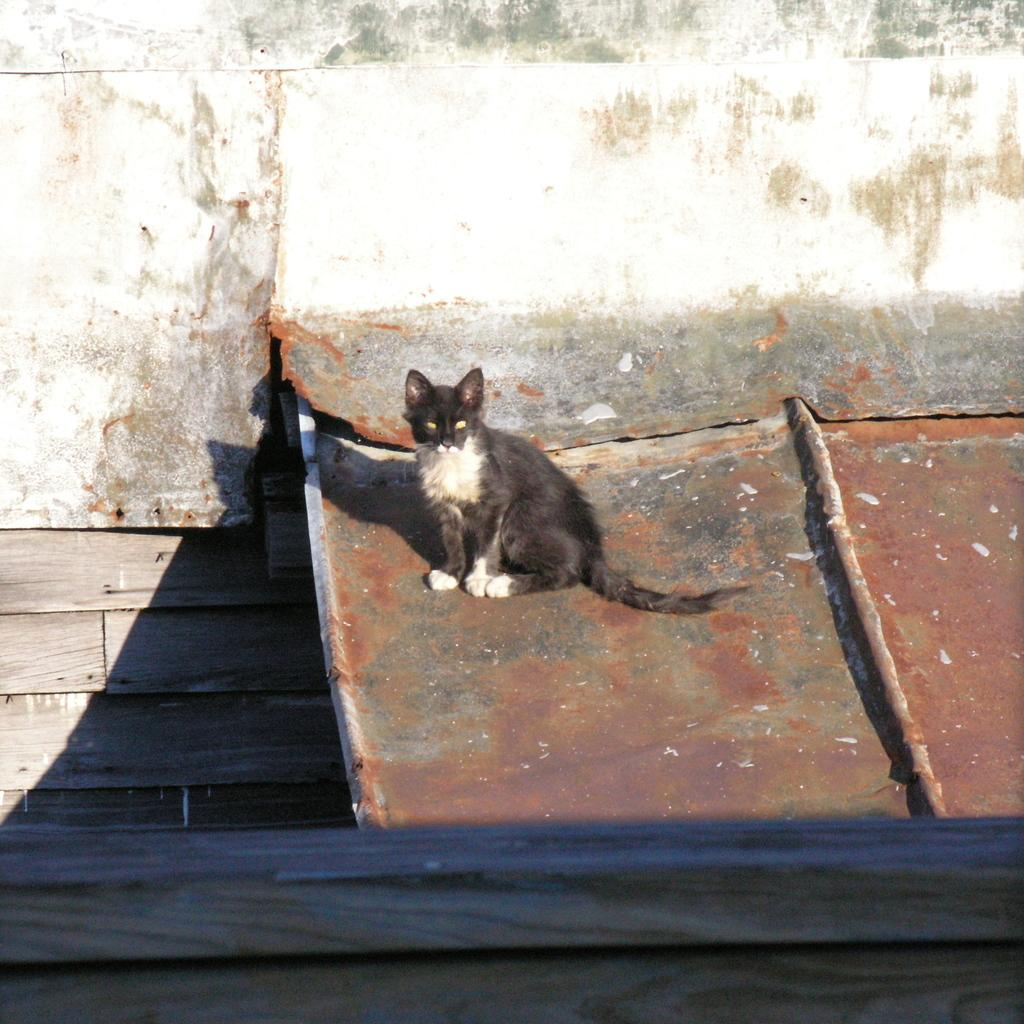What type of animal is in the image? There is a cat in the image. What color is the cat? The cat is black in color. What is the cat sitting on? The cat is sitting on a metal sheet. What type of wall is visible at the bottom of the image? There is a wooden wall at the bottom of the image. What type of polish does the cat use to maintain its fur in the image? There is no indication in the image that the cat is using any type of polish to maintain its fur. 